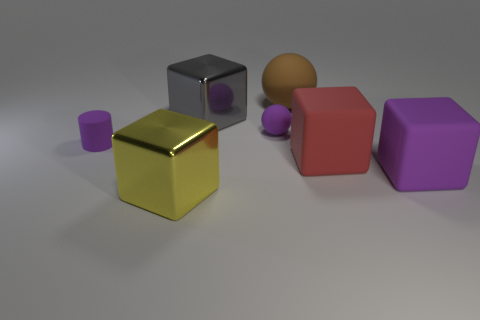What number of things have the same size as the purple cylinder?
Offer a very short reply. 1. Are the large red object that is in front of the gray metallic cube and the small purple cylinder made of the same material?
Provide a short and direct response. Yes. Is there a small brown object?
Offer a very short reply. No. What is the size of the brown ball that is the same material as the big purple cube?
Offer a terse response. Large. Are there any large objects that have the same color as the rubber cylinder?
Ensure brevity in your answer.  Yes. Is the color of the tiny object in front of the small purple matte sphere the same as the small thing on the right side of the rubber cylinder?
Ensure brevity in your answer.  Yes. The sphere that is the same color as the rubber cylinder is what size?
Give a very brief answer. Small. Is there another big yellow object made of the same material as the large yellow object?
Make the answer very short. No. The rubber cylinder is what color?
Ensure brevity in your answer.  Purple. There is a rubber sphere that is to the left of the rubber thing behind the matte ball that is in front of the brown object; what is its size?
Your response must be concise. Small. 